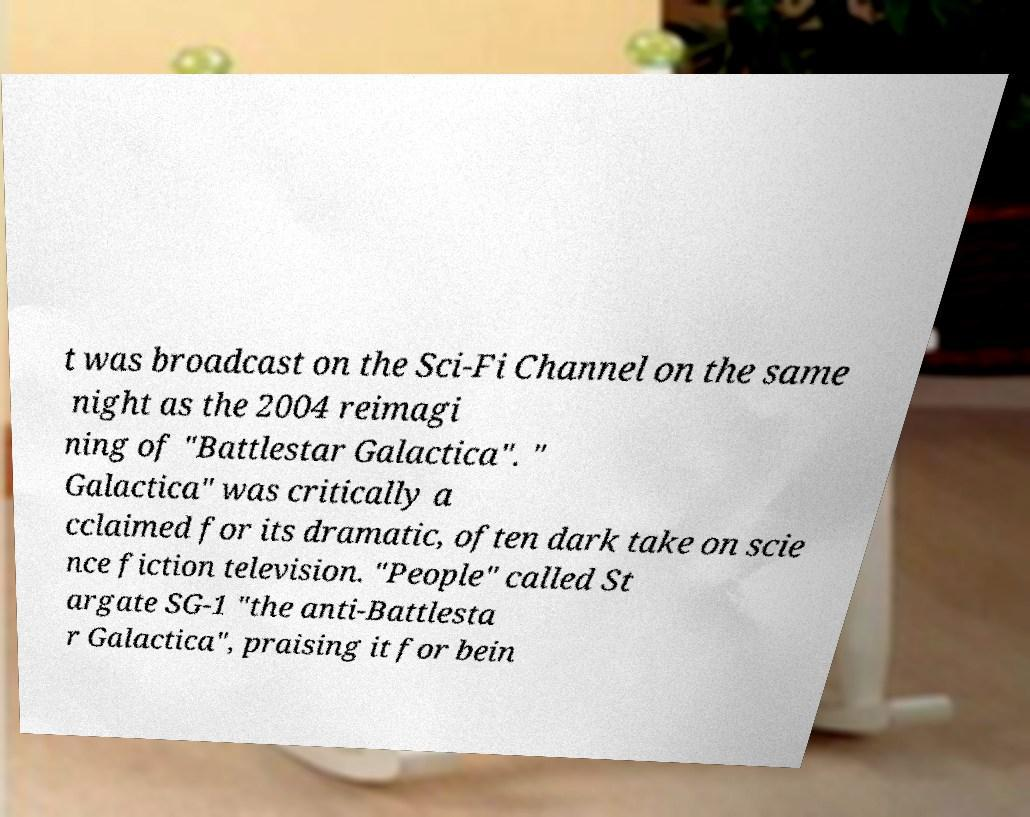There's text embedded in this image that I need extracted. Can you transcribe it verbatim? t was broadcast on the Sci-Fi Channel on the same night as the 2004 reimagi ning of "Battlestar Galactica". " Galactica" was critically a cclaimed for its dramatic, often dark take on scie nce fiction television. "People" called St argate SG-1 "the anti-Battlesta r Galactica", praising it for bein 